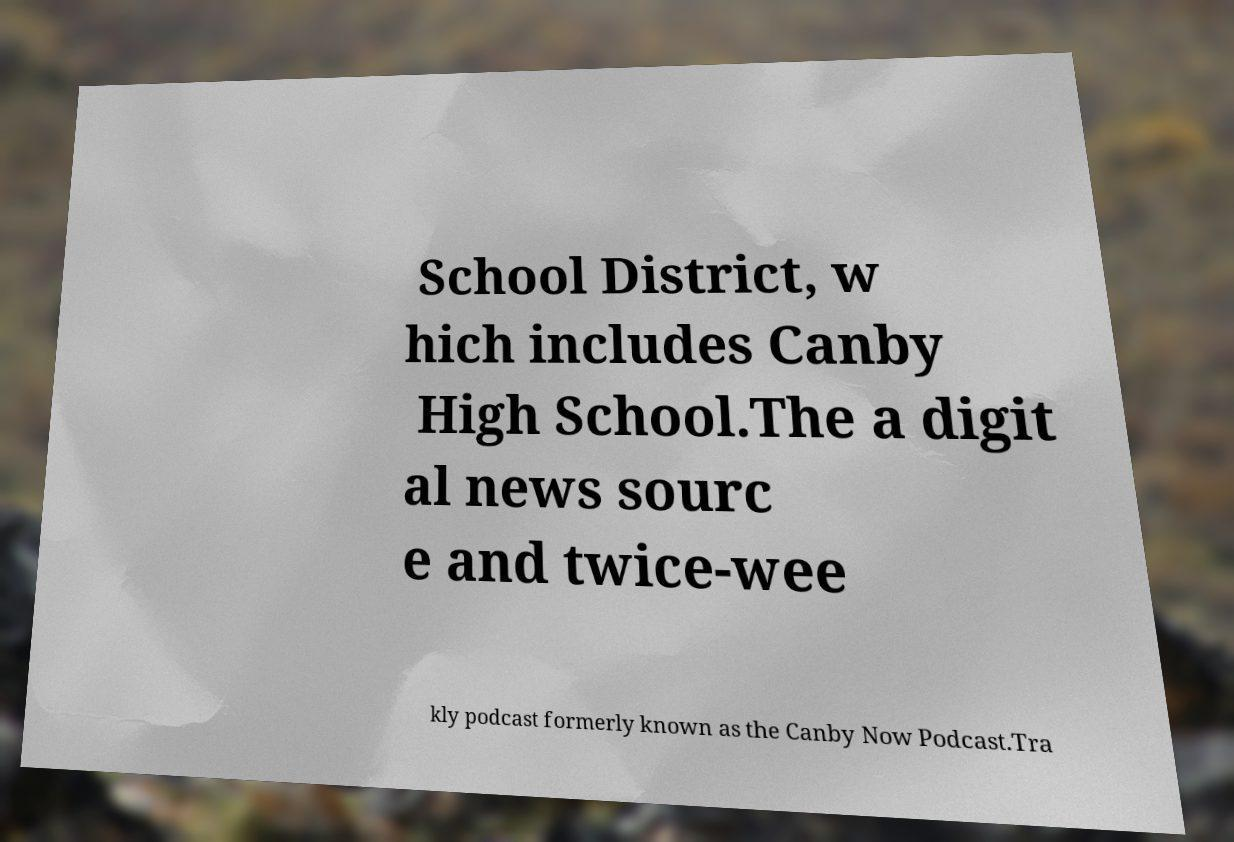Could you assist in decoding the text presented in this image and type it out clearly? School District, w hich includes Canby High School.The a digit al news sourc e and twice-wee kly podcast formerly known as the Canby Now Podcast.Tra 